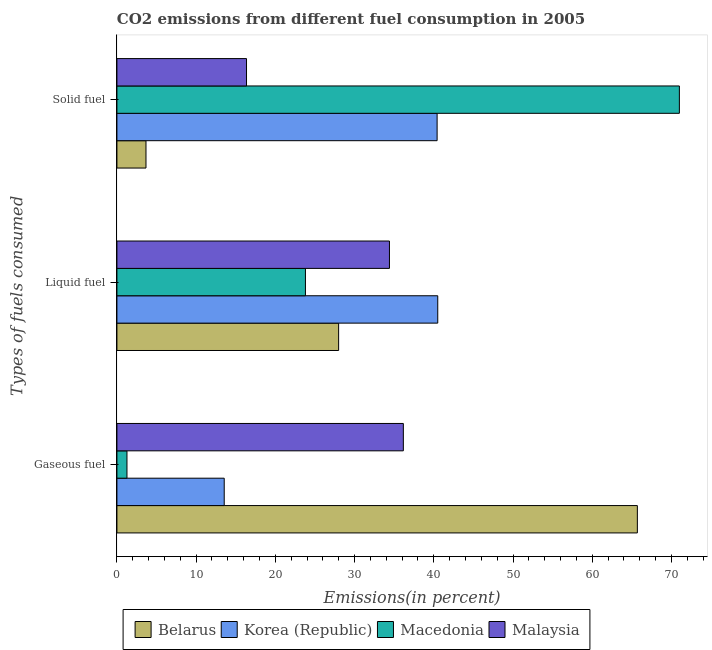How many different coloured bars are there?
Your answer should be very brief. 4. How many groups of bars are there?
Offer a terse response. 3. Are the number of bars per tick equal to the number of legend labels?
Make the answer very short. Yes. How many bars are there on the 1st tick from the bottom?
Offer a terse response. 4. What is the label of the 2nd group of bars from the top?
Provide a succinct answer. Liquid fuel. What is the percentage of liquid fuel emission in Macedonia?
Keep it short and to the point. 23.8. Across all countries, what is the maximum percentage of gaseous fuel emission?
Your response must be concise. 65.7. Across all countries, what is the minimum percentage of gaseous fuel emission?
Your response must be concise. 1.27. In which country was the percentage of solid fuel emission maximum?
Offer a terse response. Macedonia. In which country was the percentage of gaseous fuel emission minimum?
Make the answer very short. Macedonia. What is the total percentage of liquid fuel emission in the graph?
Provide a short and direct response. 126.69. What is the difference between the percentage of gaseous fuel emission in Korea (Republic) and that in Macedonia?
Your answer should be very brief. 12.28. What is the difference between the percentage of liquid fuel emission in Korea (Republic) and the percentage of solid fuel emission in Belarus?
Provide a short and direct response. 36.83. What is the average percentage of solid fuel emission per country?
Your response must be concise. 32.86. What is the difference between the percentage of liquid fuel emission and percentage of solid fuel emission in Belarus?
Offer a very short reply. 24.32. What is the ratio of the percentage of liquid fuel emission in Macedonia to that in Malaysia?
Give a very brief answer. 0.69. Is the difference between the percentage of gaseous fuel emission in Korea (Republic) and Belarus greater than the difference between the percentage of liquid fuel emission in Korea (Republic) and Belarus?
Ensure brevity in your answer.  No. What is the difference between the highest and the second highest percentage of gaseous fuel emission?
Your answer should be compact. 29.54. What is the difference between the highest and the lowest percentage of liquid fuel emission?
Your answer should be very brief. 16.7. Is the sum of the percentage of solid fuel emission in Malaysia and Macedonia greater than the maximum percentage of gaseous fuel emission across all countries?
Provide a succinct answer. Yes. What does the 4th bar from the bottom in Solid fuel represents?
Offer a terse response. Malaysia. Is it the case that in every country, the sum of the percentage of gaseous fuel emission and percentage of liquid fuel emission is greater than the percentage of solid fuel emission?
Provide a short and direct response. No. How many bars are there?
Keep it short and to the point. 12. How many countries are there in the graph?
Your answer should be compact. 4. What is the title of the graph?
Your response must be concise. CO2 emissions from different fuel consumption in 2005. Does "Sierra Leone" appear as one of the legend labels in the graph?
Your answer should be very brief. No. What is the label or title of the X-axis?
Provide a succinct answer. Emissions(in percent). What is the label or title of the Y-axis?
Provide a succinct answer. Types of fuels consumed. What is the Emissions(in percent) in Belarus in Gaseous fuel?
Your answer should be compact. 65.7. What is the Emissions(in percent) in Korea (Republic) in Gaseous fuel?
Your answer should be compact. 13.54. What is the Emissions(in percent) in Macedonia in Gaseous fuel?
Offer a very short reply. 1.27. What is the Emissions(in percent) of Malaysia in Gaseous fuel?
Keep it short and to the point. 36.16. What is the Emissions(in percent) in Belarus in Liquid fuel?
Offer a terse response. 27.99. What is the Emissions(in percent) in Korea (Republic) in Liquid fuel?
Your response must be concise. 40.5. What is the Emissions(in percent) of Macedonia in Liquid fuel?
Give a very brief answer. 23.8. What is the Emissions(in percent) in Malaysia in Liquid fuel?
Keep it short and to the point. 34.4. What is the Emissions(in percent) of Belarus in Solid fuel?
Make the answer very short. 3.67. What is the Emissions(in percent) in Korea (Republic) in Solid fuel?
Provide a succinct answer. 40.42. What is the Emissions(in percent) of Macedonia in Solid fuel?
Offer a very short reply. 71. What is the Emissions(in percent) in Malaysia in Solid fuel?
Your response must be concise. 16.36. Across all Types of fuels consumed, what is the maximum Emissions(in percent) in Belarus?
Ensure brevity in your answer.  65.7. Across all Types of fuels consumed, what is the maximum Emissions(in percent) in Korea (Republic)?
Provide a succinct answer. 40.5. Across all Types of fuels consumed, what is the maximum Emissions(in percent) in Macedonia?
Your response must be concise. 71. Across all Types of fuels consumed, what is the maximum Emissions(in percent) in Malaysia?
Your response must be concise. 36.16. Across all Types of fuels consumed, what is the minimum Emissions(in percent) in Belarus?
Provide a short and direct response. 3.67. Across all Types of fuels consumed, what is the minimum Emissions(in percent) in Korea (Republic)?
Your response must be concise. 13.54. Across all Types of fuels consumed, what is the minimum Emissions(in percent) in Macedonia?
Provide a short and direct response. 1.27. Across all Types of fuels consumed, what is the minimum Emissions(in percent) of Malaysia?
Keep it short and to the point. 16.36. What is the total Emissions(in percent) in Belarus in the graph?
Ensure brevity in your answer.  97.36. What is the total Emissions(in percent) in Korea (Republic) in the graph?
Ensure brevity in your answer.  94.46. What is the total Emissions(in percent) of Macedonia in the graph?
Give a very brief answer. 96.07. What is the total Emissions(in percent) in Malaysia in the graph?
Make the answer very short. 86.92. What is the difference between the Emissions(in percent) of Belarus in Gaseous fuel and that in Liquid fuel?
Make the answer very short. 37.71. What is the difference between the Emissions(in percent) of Korea (Republic) in Gaseous fuel and that in Liquid fuel?
Keep it short and to the point. -26.96. What is the difference between the Emissions(in percent) in Macedonia in Gaseous fuel and that in Liquid fuel?
Offer a terse response. -22.53. What is the difference between the Emissions(in percent) of Malaysia in Gaseous fuel and that in Liquid fuel?
Make the answer very short. 1.75. What is the difference between the Emissions(in percent) in Belarus in Gaseous fuel and that in Solid fuel?
Ensure brevity in your answer.  62.03. What is the difference between the Emissions(in percent) of Korea (Republic) in Gaseous fuel and that in Solid fuel?
Offer a terse response. -26.88. What is the difference between the Emissions(in percent) in Macedonia in Gaseous fuel and that in Solid fuel?
Provide a succinct answer. -69.73. What is the difference between the Emissions(in percent) of Malaysia in Gaseous fuel and that in Solid fuel?
Provide a short and direct response. 19.8. What is the difference between the Emissions(in percent) of Belarus in Liquid fuel and that in Solid fuel?
Make the answer very short. 24.32. What is the difference between the Emissions(in percent) in Macedonia in Liquid fuel and that in Solid fuel?
Give a very brief answer. -47.2. What is the difference between the Emissions(in percent) in Malaysia in Liquid fuel and that in Solid fuel?
Keep it short and to the point. 18.04. What is the difference between the Emissions(in percent) in Belarus in Gaseous fuel and the Emissions(in percent) in Korea (Republic) in Liquid fuel?
Your answer should be very brief. 25.2. What is the difference between the Emissions(in percent) in Belarus in Gaseous fuel and the Emissions(in percent) in Macedonia in Liquid fuel?
Ensure brevity in your answer.  41.9. What is the difference between the Emissions(in percent) of Belarus in Gaseous fuel and the Emissions(in percent) of Malaysia in Liquid fuel?
Offer a very short reply. 31.29. What is the difference between the Emissions(in percent) of Korea (Republic) in Gaseous fuel and the Emissions(in percent) of Macedonia in Liquid fuel?
Your response must be concise. -10.25. What is the difference between the Emissions(in percent) of Korea (Republic) in Gaseous fuel and the Emissions(in percent) of Malaysia in Liquid fuel?
Provide a succinct answer. -20.86. What is the difference between the Emissions(in percent) of Macedonia in Gaseous fuel and the Emissions(in percent) of Malaysia in Liquid fuel?
Your response must be concise. -33.14. What is the difference between the Emissions(in percent) of Belarus in Gaseous fuel and the Emissions(in percent) of Korea (Republic) in Solid fuel?
Ensure brevity in your answer.  25.28. What is the difference between the Emissions(in percent) of Belarus in Gaseous fuel and the Emissions(in percent) of Macedonia in Solid fuel?
Make the answer very short. -5.3. What is the difference between the Emissions(in percent) of Belarus in Gaseous fuel and the Emissions(in percent) of Malaysia in Solid fuel?
Give a very brief answer. 49.34. What is the difference between the Emissions(in percent) of Korea (Republic) in Gaseous fuel and the Emissions(in percent) of Macedonia in Solid fuel?
Ensure brevity in your answer.  -57.46. What is the difference between the Emissions(in percent) in Korea (Republic) in Gaseous fuel and the Emissions(in percent) in Malaysia in Solid fuel?
Ensure brevity in your answer.  -2.82. What is the difference between the Emissions(in percent) of Macedonia in Gaseous fuel and the Emissions(in percent) of Malaysia in Solid fuel?
Ensure brevity in your answer.  -15.09. What is the difference between the Emissions(in percent) in Belarus in Liquid fuel and the Emissions(in percent) in Korea (Republic) in Solid fuel?
Make the answer very short. -12.43. What is the difference between the Emissions(in percent) in Belarus in Liquid fuel and the Emissions(in percent) in Macedonia in Solid fuel?
Your answer should be compact. -43.01. What is the difference between the Emissions(in percent) in Belarus in Liquid fuel and the Emissions(in percent) in Malaysia in Solid fuel?
Make the answer very short. 11.63. What is the difference between the Emissions(in percent) of Korea (Republic) in Liquid fuel and the Emissions(in percent) of Macedonia in Solid fuel?
Provide a short and direct response. -30.5. What is the difference between the Emissions(in percent) of Korea (Republic) in Liquid fuel and the Emissions(in percent) of Malaysia in Solid fuel?
Offer a terse response. 24.14. What is the difference between the Emissions(in percent) of Macedonia in Liquid fuel and the Emissions(in percent) of Malaysia in Solid fuel?
Provide a short and direct response. 7.44. What is the average Emissions(in percent) in Belarus per Types of fuels consumed?
Give a very brief answer. 32.45. What is the average Emissions(in percent) in Korea (Republic) per Types of fuels consumed?
Your answer should be compact. 31.49. What is the average Emissions(in percent) in Macedonia per Types of fuels consumed?
Offer a terse response. 32.02. What is the average Emissions(in percent) of Malaysia per Types of fuels consumed?
Your response must be concise. 28.97. What is the difference between the Emissions(in percent) of Belarus and Emissions(in percent) of Korea (Republic) in Gaseous fuel?
Your response must be concise. 52.15. What is the difference between the Emissions(in percent) in Belarus and Emissions(in percent) in Macedonia in Gaseous fuel?
Offer a very short reply. 64.43. What is the difference between the Emissions(in percent) of Belarus and Emissions(in percent) of Malaysia in Gaseous fuel?
Your answer should be very brief. 29.54. What is the difference between the Emissions(in percent) in Korea (Republic) and Emissions(in percent) in Macedonia in Gaseous fuel?
Give a very brief answer. 12.28. What is the difference between the Emissions(in percent) in Korea (Republic) and Emissions(in percent) in Malaysia in Gaseous fuel?
Offer a very short reply. -22.61. What is the difference between the Emissions(in percent) in Macedonia and Emissions(in percent) in Malaysia in Gaseous fuel?
Your response must be concise. -34.89. What is the difference between the Emissions(in percent) of Belarus and Emissions(in percent) of Korea (Republic) in Liquid fuel?
Your answer should be compact. -12.51. What is the difference between the Emissions(in percent) in Belarus and Emissions(in percent) in Macedonia in Liquid fuel?
Your response must be concise. 4.19. What is the difference between the Emissions(in percent) of Belarus and Emissions(in percent) of Malaysia in Liquid fuel?
Your answer should be very brief. -6.42. What is the difference between the Emissions(in percent) of Korea (Republic) and Emissions(in percent) of Macedonia in Liquid fuel?
Your answer should be very brief. 16.7. What is the difference between the Emissions(in percent) in Korea (Republic) and Emissions(in percent) in Malaysia in Liquid fuel?
Offer a very short reply. 6.1. What is the difference between the Emissions(in percent) in Macedonia and Emissions(in percent) in Malaysia in Liquid fuel?
Your answer should be very brief. -10.61. What is the difference between the Emissions(in percent) of Belarus and Emissions(in percent) of Korea (Republic) in Solid fuel?
Provide a short and direct response. -36.75. What is the difference between the Emissions(in percent) of Belarus and Emissions(in percent) of Macedonia in Solid fuel?
Your answer should be very brief. -67.33. What is the difference between the Emissions(in percent) in Belarus and Emissions(in percent) in Malaysia in Solid fuel?
Keep it short and to the point. -12.69. What is the difference between the Emissions(in percent) in Korea (Republic) and Emissions(in percent) in Macedonia in Solid fuel?
Provide a short and direct response. -30.58. What is the difference between the Emissions(in percent) of Korea (Republic) and Emissions(in percent) of Malaysia in Solid fuel?
Your answer should be very brief. 24.06. What is the difference between the Emissions(in percent) of Macedonia and Emissions(in percent) of Malaysia in Solid fuel?
Your answer should be compact. 54.64. What is the ratio of the Emissions(in percent) in Belarus in Gaseous fuel to that in Liquid fuel?
Offer a very short reply. 2.35. What is the ratio of the Emissions(in percent) of Korea (Republic) in Gaseous fuel to that in Liquid fuel?
Your answer should be very brief. 0.33. What is the ratio of the Emissions(in percent) in Macedonia in Gaseous fuel to that in Liquid fuel?
Offer a terse response. 0.05. What is the ratio of the Emissions(in percent) in Malaysia in Gaseous fuel to that in Liquid fuel?
Your response must be concise. 1.05. What is the ratio of the Emissions(in percent) of Belarus in Gaseous fuel to that in Solid fuel?
Your answer should be very brief. 17.91. What is the ratio of the Emissions(in percent) of Korea (Republic) in Gaseous fuel to that in Solid fuel?
Provide a succinct answer. 0.34. What is the ratio of the Emissions(in percent) in Macedonia in Gaseous fuel to that in Solid fuel?
Offer a very short reply. 0.02. What is the ratio of the Emissions(in percent) of Malaysia in Gaseous fuel to that in Solid fuel?
Make the answer very short. 2.21. What is the ratio of the Emissions(in percent) of Belarus in Liquid fuel to that in Solid fuel?
Your response must be concise. 7.63. What is the ratio of the Emissions(in percent) in Korea (Republic) in Liquid fuel to that in Solid fuel?
Provide a short and direct response. 1. What is the ratio of the Emissions(in percent) in Macedonia in Liquid fuel to that in Solid fuel?
Give a very brief answer. 0.34. What is the ratio of the Emissions(in percent) in Malaysia in Liquid fuel to that in Solid fuel?
Give a very brief answer. 2.1. What is the difference between the highest and the second highest Emissions(in percent) in Belarus?
Provide a short and direct response. 37.71. What is the difference between the highest and the second highest Emissions(in percent) in Macedonia?
Your response must be concise. 47.2. What is the difference between the highest and the second highest Emissions(in percent) of Malaysia?
Keep it short and to the point. 1.75. What is the difference between the highest and the lowest Emissions(in percent) in Belarus?
Provide a short and direct response. 62.03. What is the difference between the highest and the lowest Emissions(in percent) in Korea (Republic)?
Give a very brief answer. 26.96. What is the difference between the highest and the lowest Emissions(in percent) in Macedonia?
Give a very brief answer. 69.73. What is the difference between the highest and the lowest Emissions(in percent) in Malaysia?
Provide a succinct answer. 19.8. 